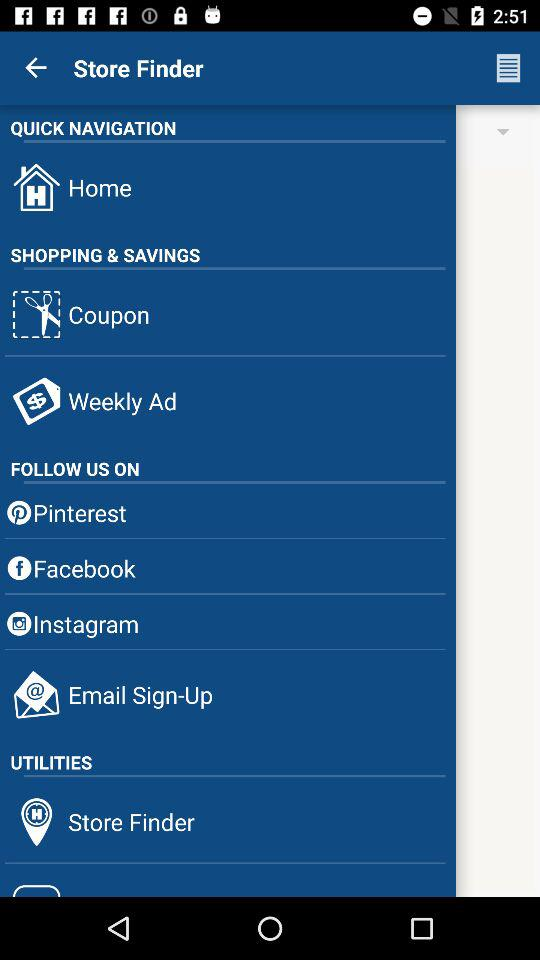What social media platforms can be used to follow? The social media platforms are "Pinterast", "Facebook" and "Instagram". 